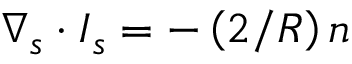<formula> <loc_0><loc_0><loc_500><loc_500>\nabla _ { s } \cdot I _ { s } = - \left ( { 2 } / { R } \right ) n</formula> 